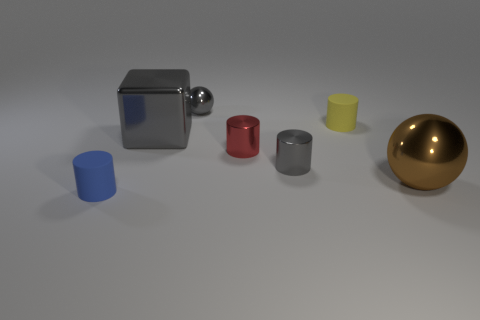What size is the cube that is the same material as the small gray cylinder?
Offer a very short reply. Large. How many green objects are large objects or shiny things?
Offer a terse response. 0. What is the shape of the small metal thing that is the same color as the tiny shiny sphere?
Provide a short and direct response. Cylinder. There is a matte object left of the gray shiny ball; does it have the same shape as the tiny gray metal thing that is in front of the small yellow object?
Ensure brevity in your answer.  Yes. What number of tiny gray things are there?
Provide a short and direct response. 2. What is the shape of the big brown thing that is the same material as the tiny ball?
Ensure brevity in your answer.  Sphere. Are there any other things that have the same color as the big metallic ball?
Ensure brevity in your answer.  No. There is a tiny sphere; does it have the same color as the big metal thing that is left of the tiny gray metal ball?
Offer a terse response. Yes. Are there fewer yellow cylinders that are in front of the large shiny sphere than small blue metal spheres?
Offer a terse response. No. What is the material of the big thing in front of the big gray thing?
Your answer should be very brief. Metal. 